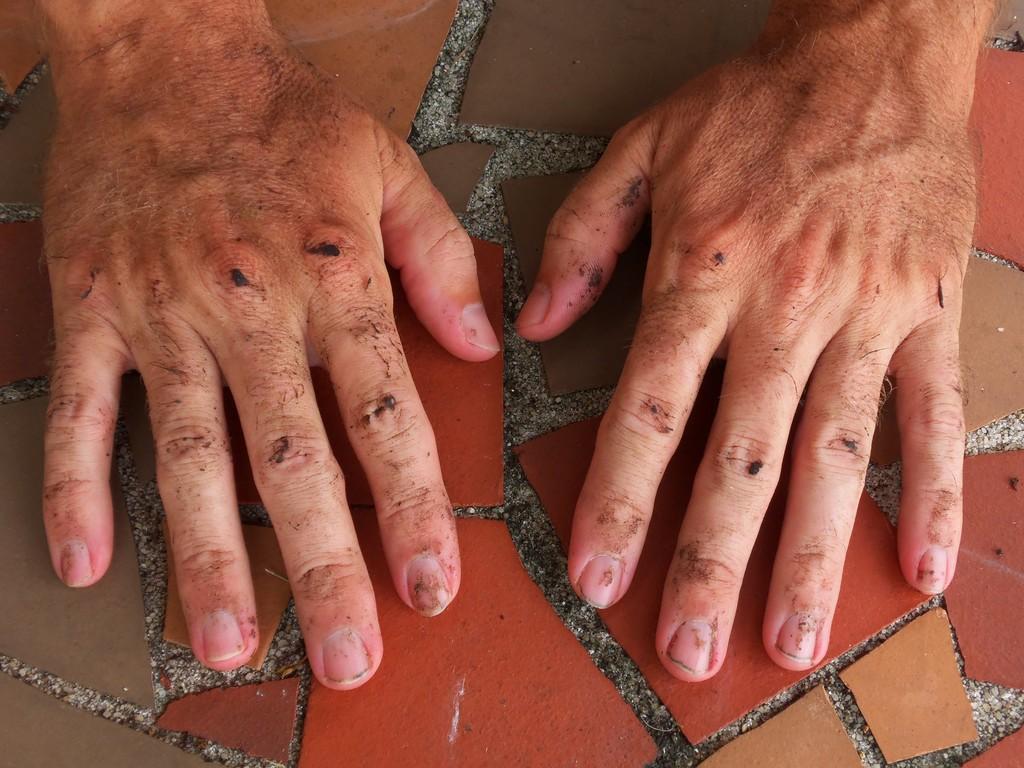Please provide a concise description of this image. In this picture we can observe hands of a man placed on the floor. We can observe red and brown color tiles on the floor. 